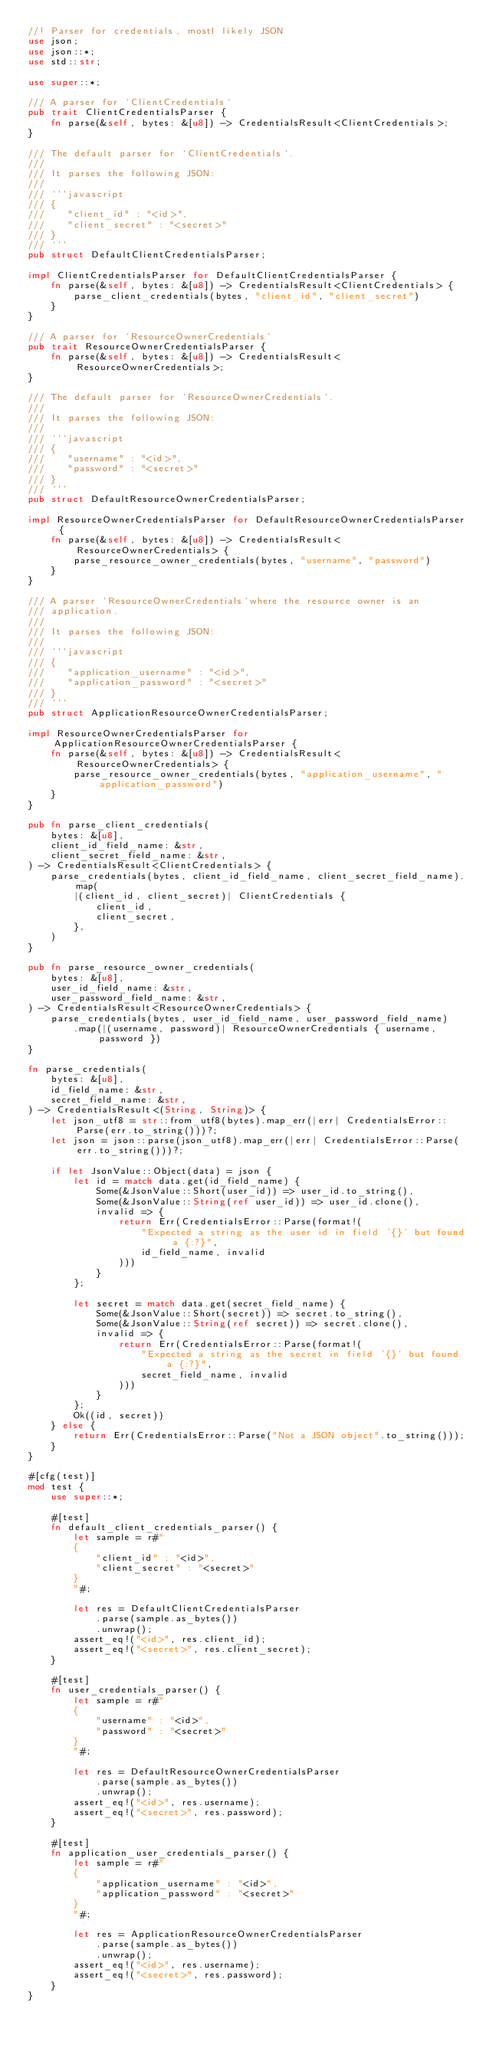Convert code to text. <code><loc_0><loc_0><loc_500><loc_500><_Rust_>//! Parser for credentials, mostl likely JSON
use json;
use json::*;
use std::str;

use super::*;

/// A parser for `ClientCredentials`
pub trait ClientCredentialsParser {
    fn parse(&self, bytes: &[u8]) -> CredentialsResult<ClientCredentials>;
}

/// The default parser for `ClientCredentials`.
///
/// It parses the following JSON:
///
/// ```javascript
/// {
///    "client_id" : "<id>",
///    "client_secret" : "<secret>"
/// }
/// ```
pub struct DefaultClientCredentialsParser;

impl ClientCredentialsParser for DefaultClientCredentialsParser {
    fn parse(&self, bytes: &[u8]) -> CredentialsResult<ClientCredentials> {
        parse_client_credentials(bytes, "client_id", "client_secret")
    }
}

/// A parser for `ResourceOwnerCredentials`
pub trait ResourceOwnerCredentialsParser {
    fn parse(&self, bytes: &[u8]) -> CredentialsResult<ResourceOwnerCredentials>;
}

/// The default parser for `ResourceOwnerCredentials`.
///
/// It parses the following JSON:
///
/// ```javascript
/// {
///    "username" : "<id>",
///    "password" : "<secret>"
/// }
/// ```
pub struct DefaultResourceOwnerCredentialsParser;

impl ResourceOwnerCredentialsParser for DefaultResourceOwnerCredentialsParser {
    fn parse(&self, bytes: &[u8]) -> CredentialsResult<ResourceOwnerCredentials> {
        parse_resource_owner_credentials(bytes, "username", "password")
    }
}

/// A parser `ResourceOwnerCredentials`where the resource owner is an
/// application.
///
/// It parses the following JSON:
///
/// ```javascript
/// {
///    "application_username" : "<id>",
///    "application_password" : "<secret>"
/// }
/// ```
pub struct ApplicationResourceOwnerCredentialsParser;

impl ResourceOwnerCredentialsParser for ApplicationResourceOwnerCredentialsParser {
    fn parse(&self, bytes: &[u8]) -> CredentialsResult<ResourceOwnerCredentials> {
        parse_resource_owner_credentials(bytes, "application_username", "application_password")
    }
}

pub fn parse_client_credentials(
    bytes: &[u8],
    client_id_field_name: &str,
    client_secret_field_name: &str,
) -> CredentialsResult<ClientCredentials> {
    parse_credentials(bytes, client_id_field_name, client_secret_field_name).map(
        |(client_id, client_secret)| ClientCredentials {
            client_id,
            client_secret,
        },
    )
}

pub fn parse_resource_owner_credentials(
    bytes: &[u8],
    user_id_field_name: &str,
    user_password_field_name: &str,
) -> CredentialsResult<ResourceOwnerCredentials> {
    parse_credentials(bytes, user_id_field_name, user_password_field_name)
        .map(|(username, password)| ResourceOwnerCredentials { username, password })
}

fn parse_credentials(
    bytes: &[u8],
    id_field_name: &str,
    secret_field_name: &str,
) -> CredentialsResult<(String, String)> {
    let json_utf8 = str::from_utf8(bytes).map_err(|err| CredentialsError::Parse(err.to_string()))?;
    let json = json::parse(json_utf8).map_err(|err| CredentialsError::Parse(err.to_string()))?;

    if let JsonValue::Object(data) = json {
        let id = match data.get(id_field_name) {
            Some(&JsonValue::Short(user_id)) => user_id.to_string(),
            Some(&JsonValue::String(ref user_id)) => user_id.clone(),
            invalid => {
                return Err(CredentialsError::Parse(format!(
                    "Expected a string as the user id in field '{}' but found a {:?}",
                    id_field_name, invalid
                )))
            }
        };

        let secret = match data.get(secret_field_name) {
            Some(&JsonValue::Short(secret)) => secret.to_string(),
            Some(&JsonValue::String(ref secret)) => secret.clone(),
            invalid => {
                return Err(CredentialsError::Parse(format!(
                    "Expected a string as the secret in field '{}' but found a {:?}",
                    secret_field_name, invalid
                )))
            }
        };
        Ok((id, secret))
    } else {
        return Err(CredentialsError::Parse("Not a JSON object".to_string()));
    }
}

#[cfg(test)]
mod test {
    use super::*;

    #[test]
    fn default_client_credentials_parser() {
        let sample = r#"
        {
            "client_id" : "<id>",
            "client_secret" : "<secret>"
        }
        "#;

        let res = DefaultClientCredentialsParser
            .parse(sample.as_bytes())
            .unwrap();
        assert_eq!("<id>", res.client_id);
        assert_eq!("<secret>", res.client_secret);
    }

    #[test]
    fn user_credentials_parser() {
        let sample = r#"
        {
            "username" : "<id>",
            "password" : "<secret>"
        }
        "#;

        let res = DefaultResourceOwnerCredentialsParser
            .parse(sample.as_bytes())
            .unwrap();
        assert_eq!("<id>", res.username);
        assert_eq!("<secret>", res.password);
    }

    #[test]
    fn application_user_credentials_parser() {
        let sample = r#"
        {
            "application_username" : "<id>",
            "application_password" : "<secret>"
        }
        "#;

        let res = ApplicationResourceOwnerCredentialsParser
            .parse(sample.as_bytes())
            .unwrap();
        assert_eq!("<id>", res.username);
        assert_eq!("<secret>", res.password);
    }
}
</code> 